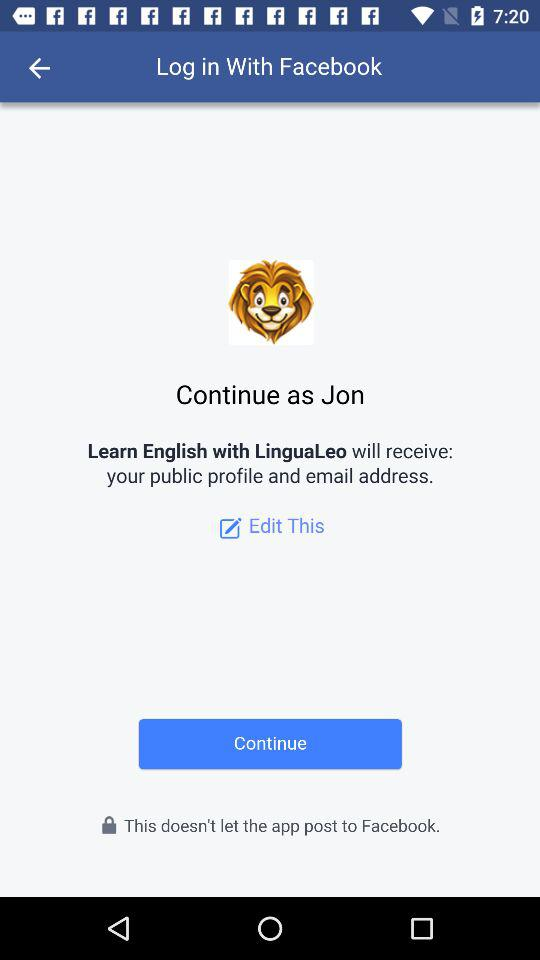Through what application can we log in? You can login through "Facebook". 